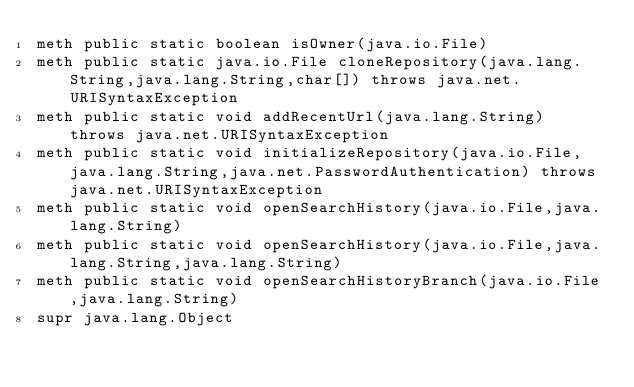<code> <loc_0><loc_0><loc_500><loc_500><_SML_>meth public static boolean isOwner(java.io.File)
meth public static java.io.File cloneRepository(java.lang.String,java.lang.String,char[]) throws java.net.URISyntaxException
meth public static void addRecentUrl(java.lang.String) throws java.net.URISyntaxException
meth public static void initializeRepository(java.io.File,java.lang.String,java.net.PasswordAuthentication) throws java.net.URISyntaxException
meth public static void openSearchHistory(java.io.File,java.lang.String)
meth public static void openSearchHistory(java.io.File,java.lang.String,java.lang.String)
meth public static void openSearchHistoryBranch(java.io.File,java.lang.String)
supr java.lang.Object

</code> 